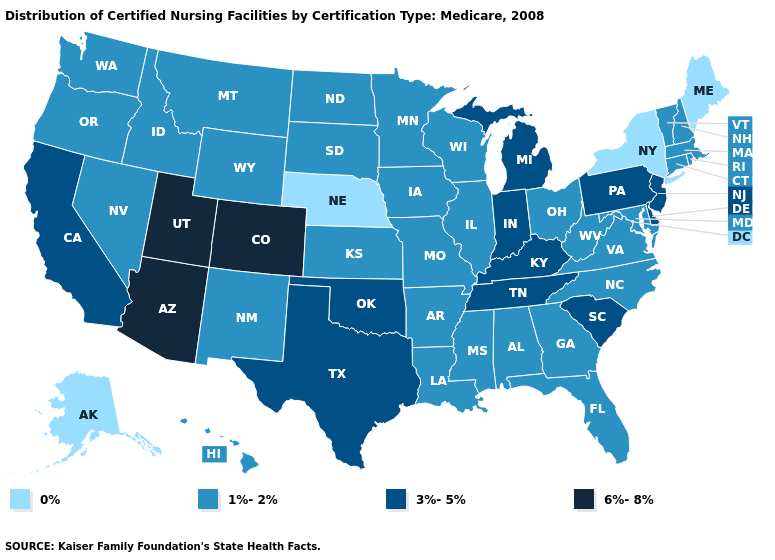Name the states that have a value in the range 3%-5%?
Give a very brief answer. California, Delaware, Indiana, Kentucky, Michigan, New Jersey, Oklahoma, Pennsylvania, South Carolina, Tennessee, Texas. Which states have the lowest value in the South?
Be succinct. Alabama, Arkansas, Florida, Georgia, Louisiana, Maryland, Mississippi, North Carolina, Virginia, West Virginia. What is the lowest value in the USA?
Keep it brief. 0%. Name the states that have a value in the range 3%-5%?
Concise answer only. California, Delaware, Indiana, Kentucky, Michigan, New Jersey, Oklahoma, Pennsylvania, South Carolina, Tennessee, Texas. What is the highest value in states that border Mississippi?
Keep it brief. 3%-5%. What is the lowest value in states that border Virginia?
Quick response, please. 1%-2%. Name the states that have a value in the range 1%-2%?
Concise answer only. Alabama, Arkansas, Connecticut, Florida, Georgia, Hawaii, Idaho, Illinois, Iowa, Kansas, Louisiana, Maryland, Massachusetts, Minnesota, Mississippi, Missouri, Montana, Nevada, New Hampshire, New Mexico, North Carolina, North Dakota, Ohio, Oregon, Rhode Island, South Dakota, Vermont, Virginia, Washington, West Virginia, Wisconsin, Wyoming. Name the states that have a value in the range 0%?
Keep it brief. Alaska, Maine, Nebraska, New York. Name the states that have a value in the range 6%-8%?
Short answer required. Arizona, Colorado, Utah. What is the highest value in states that border Washington?
Concise answer only. 1%-2%. Is the legend a continuous bar?
Concise answer only. No. Which states have the lowest value in the USA?
Short answer required. Alaska, Maine, Nebraska, New York. What is the highest value in states that border Mississippi?
Give a very brief answer. 3%-5%. Among the states that border Vermont , which have the lowest value?
Answer briefly. New York. Name the states that have a value in the range 3%-5%?
Give a very brief answer. California, Delaware, Indiana, Kentucky, Michigan, New Jersey, Oklahoma, Pennsylvania, South Carolina, Tennessee, Texas. 